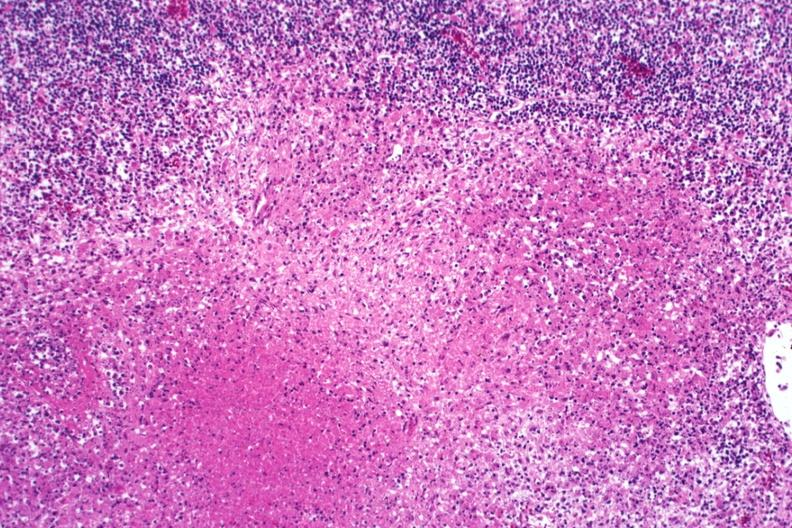s lymph node present?
Answer the question using a single word or phrase. Yes 